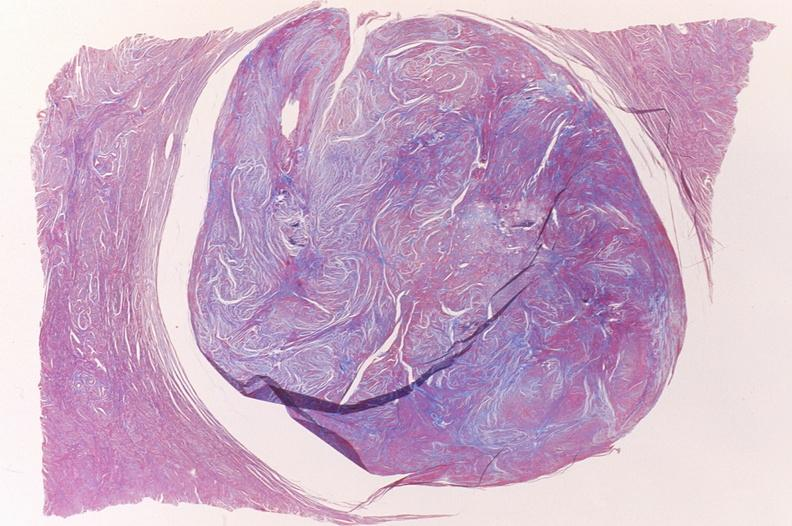where is this from?
Answer the question using a single word or phrase. Female reproductive system 